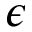<formula> <loc_0><loc_0><loc_500><loc_500>\epsilon</formula> 